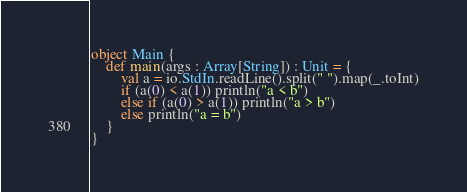<code> <loc_0><loc_0><loc_500><loc_500><_Scala_>
object Main {
    def main(args : Array[String]) : Unit = {
        val a = io.StdIn.readLine().split(" ").map(_.toInt)
        if (a(0) < a(1)) println("a < b")
        else if (a(0) > a(1)) println("a > b")
        else println("a = b")
    }
}</code> 